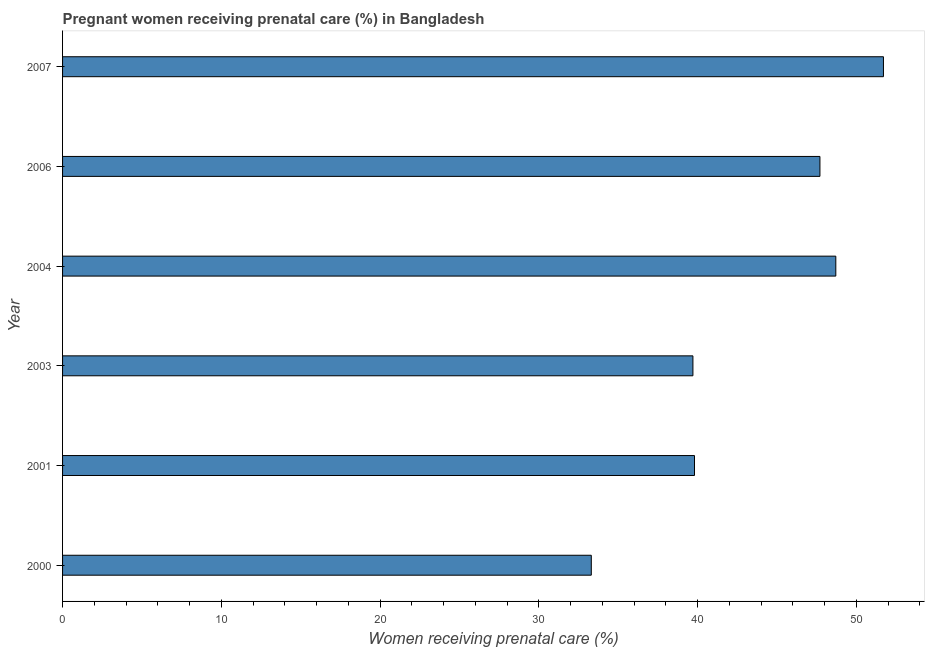Does the graph contain any zero values?
Provide a short and direct response. No. What is the title of the graph?
Offer a terse response. Pregnant women receiving prenatal care (%) in Bangladesh. What is the label or title of the X-axis?
Your response must be concise. Women receiving prenatal care (%). What is the label or title of the Y-axis?
Provide a succinct answer. Year. What is the percentage of pregnant women receiving prenatal care in 2003?
Your response must be concise. 39.7. Across all years, what is the maximum percentage of pregnant women receiving prenatal care?
Offer a terse response. 51.7. Across all years, what is the minimum percentage of pregnant women receiving prenatal care?
Your answer should be compact. 33.3. In which year was the percentage of pregnant women receiving prenatal care maximum?
Give a very brief answer. 2007. In which year was the percentage of pregnant women receiving prenatal care minimum?
Give a very brief answer. 2000. What is the sum of the percentage of pregnant women receiving prenatal care?
Your answer should be very brief. 260.9. What is the difference between the percentage of pregnant women receiving prenatal care in 2001 and 2003?
Keep it short and to the point. 0.1. What is the average percentage of pregnant women receiving prenatal care per year?
Make the answer very short. 43.48. What is the median percentage of pregnant women receiving prenatal care?
Ensure brevity in your answer.  43.75. In how many years, is the percentage of pregnant women receiving prenatal care greater than 44 %?
Give a very brief answer. 3. What is the ratio of the percentage of pregnant women receiving prenatal care in 2001 to that in 2006?
Provide a succinct answer. 0.83. Is the difference between the percentage of pregnant women receiving prenatal care in 2003 and 2004 greater than the difference between any two years?
Ensure brevity in your answer.  No. What is the difference between the highest and the second highest percentage of pregnant women receiving prenatal care?
Your answer should be compact. 3. In how many years, is the percentage of pregnant women receiving prenatal care greater than the average percentage of pregnant women receiving prenatal care taken over all years?
Ensure brevity in your answer.  3. How many bars are there?
Keep it short and to the point. 6. Are all the bars in the graph horizontal?
Your answer should be very brief. Yes. What is the difference between two consecutive major ticks on the X-axis?
Make the answer very short. 10. Are the values on the major ticks of X-axis written in scientific E-notation?
Provide a short and direct response. No. What is the Women receiving prenatal care (%) of 2000?
Offer a terse response. 33.3. What is the Women receiving prenatal care (%) in 2001?
Ensure brevity in your answer.  39.8. What is the Women receiving prenatal care (%) of 2003?
Make the answer very short. 39.7. What is the Women receiving prenatal care (%) in 2004?
Ensure brevity in your answer.  48.7. What is the Women receiving prenatal care (%) of 2006?
Provide a short and direct response. 47.7. What is the Women receiving prenatal care (%) of 2007?
Provide a short and direct response. 51.7. What is the difference between the Women receiving prenatal care (%) in 2000 and 2003?
Your answer should be compact. -6.4. What is the difference between the Women receiving prenatal care (%) in 2000 and 2004?
Make the answer very short. -15.4. What is the difference between the Women receiving prenatal care (%) in 2000 and 2006?
Offer a terse response. -14.4. What is the difference between the Women receiving prenatal care (%) in 2000 and 2007?
Provide a short and direct response. -18.4. What is the difference between the Women receiving prenatal care (%) in 2001 and 2003?
Provide a succinct answer. 0.1. What is the difference between the Women receiving prenatal care (%) in 2001 and 2004?
Offer a terse response. -8.9. What is the difference between the Women receiving prenatal care (%) in 2001 and 2007?
Keep it short and to the point. -11.9. What is the difference between the Women receiving prenatal care (%) in 2003 and 2006?
Ensure brevity in your answer.  -8. What is the difference between the Women receiving prenatal care (%) in 2004 and 2006?
Provide a short and direct response. 1. What is the ratio of the Women receiving prenatal care (%) in 2000 to that in 2001?
Keep it short and to the point. 0.84. What is the ratio of the Women receiving prenatal care (%) in 2000 to that in 2003?
Ensure brevity in your answer.  0.84. What is the ratio of the Women receiving prenatal care (%) in 2000 to that in 2004?
Provide a succinct answer. 0.68. What is the ratio of the Women receiving prenatal care (%) in 2000 to that in 2006?
Offer a terse response. 0.7. What is the ratio of the Women receiving prenatal care (%) in 2000 to that in 2007?
Ensure brevity in your answer.  0.64. What is the ratio of the Women receiving prenatal care (%) in 2001 to that in 2003?
Your response must be concise. 1. What is the ratio of the Women receiving prenatal care (%) in 2001 to that in 2004?
Make the answer very short. 0.82. What is the ratio of the Women receiving prenatal care (%) in 2001 to that in 2006?
Offer a terse response. 0.83. What is the ratio of the Women receiving prenatal care (%) in 2001 to that in 2007?
Provide a succinct answer. 0.77. What is the ratio of the Women receiving prenatal care (%) in 2003 to that in 2004?
Provide a short and direct response. 0.81. What is the ratio of the Women receiving prenatal care (%) in 2003 to that in 2006?
Your answer should be compact. 0.83. What is the ratio of the Women receiving prenatal care (%) in 2003 to that in 2007?
Your response must be concise. 0.77. What is the ratio of the Women receiving prenatal care (%) in 2004 to that in 2006?
Offer a very short reply. 1.02. What is the ratio of the Women receiving prenatal care (%) in 2004 to that in 2007?
Keep it short and to the point. 0.94. What is the ratio of the Women receiving prenatal care (%) in 2006 to that in 2007?
Your answer should be compact. 0.92. 